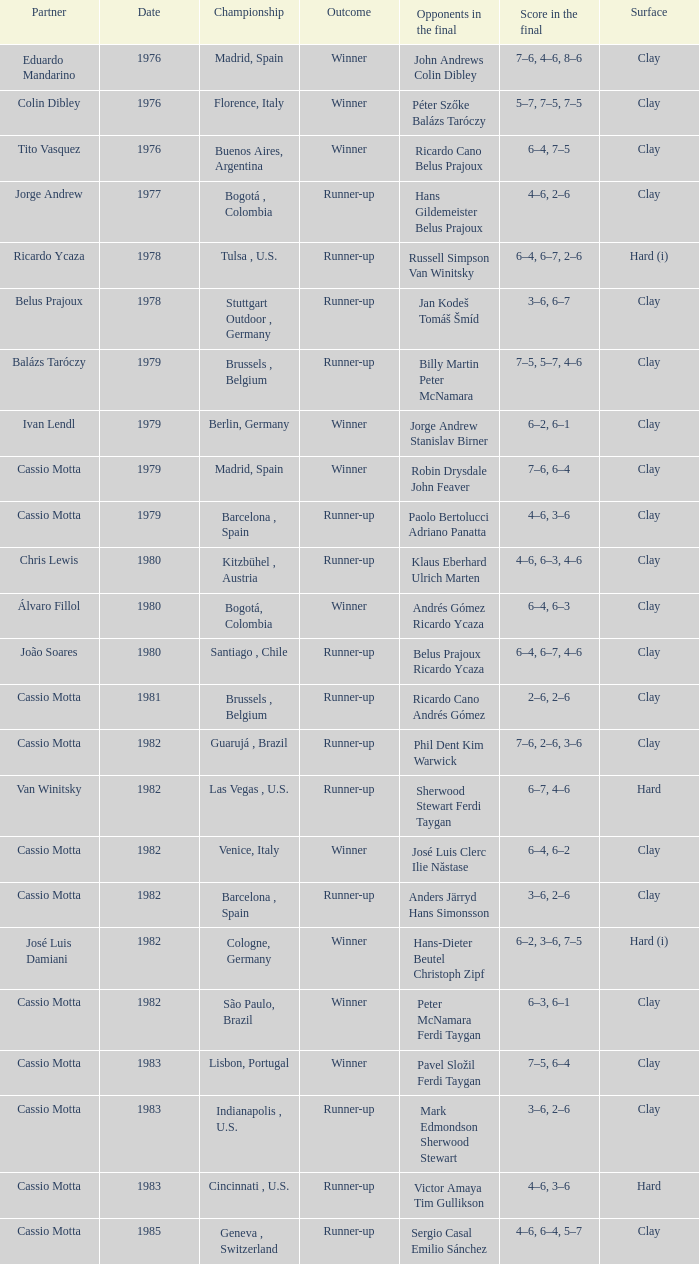What was the surface in 1981? Clay. 